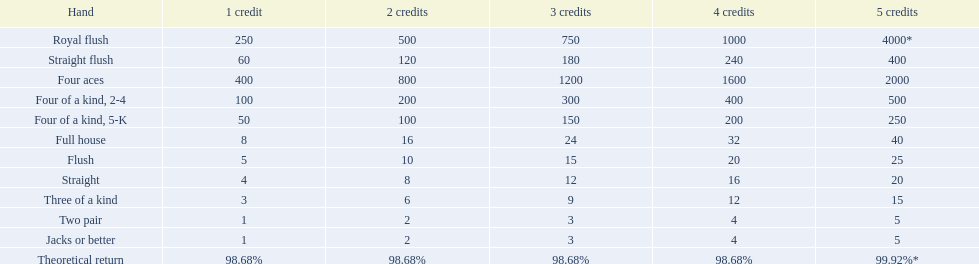Which hand is beneath a straight flush? Four aces. Which hand is inferior to four aces? Four of a kind, 2-4. Which hand is superior between a straight and a flush? Flush. 